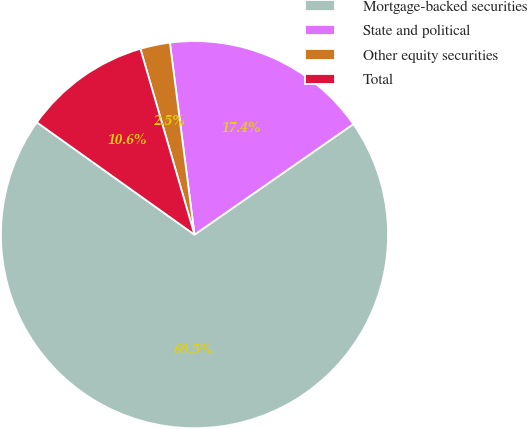Convert chart. <chart><loc_0><loc_0><loc_500><loc_500><pie_chart><fcel>Mortgage-backed securities<fcel>State and political<fcel>Other equity securities<fcel>Total<nl><fcel>69.53%<fcel>17.35%<fcel>2.48%<fcel>10.64%<nl></chart> 